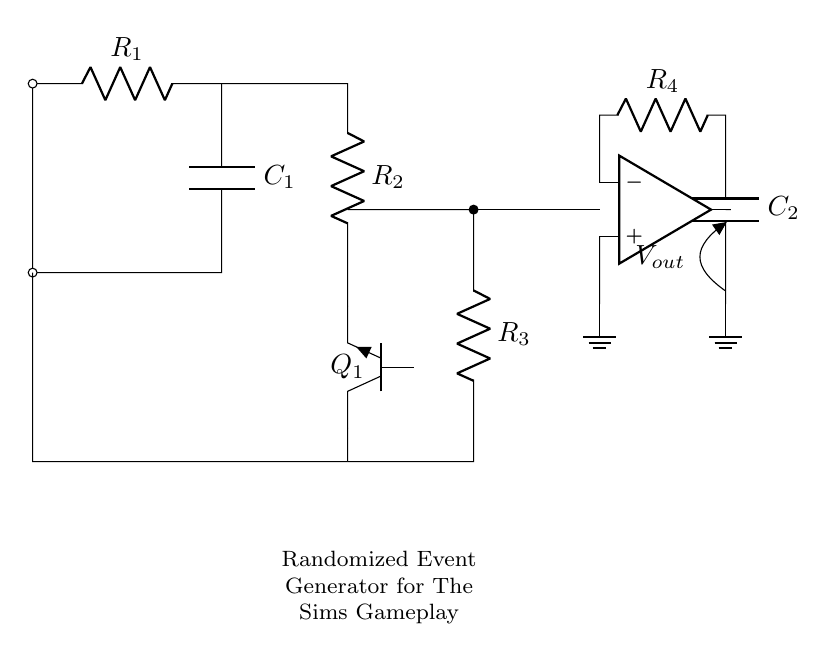What is the function of the capacitor in this circuit? The capacitor in this circuit is responsible for storing and releasing energy, which contributes to the timing and oscillation behavior of the relaxation oscillator. Specifically, it helps to create the charge and discharge cycles that produce randomized events.
Answer: Energy storage What type of transistor is used in this circuit? The circuit features an NPN transistor, typically used in oscillators for switching and amplification purposes. Its designation as Q1 indicates it is the primary component responsible for initiating the oscillation.
Answer: NPN What is the role of resistor R1? Resistor R1 is essential for limiting the current flowing into the charging capacitor, which in turn affects the time it takes to charge and discharge, influencing the frequency of oscillation.
Answer: Current limiting How many resistors are present in the circuit? Upon examining the circuit diagram, we count four resistors labeled R1, R2, R3, and R4, indicating their presence in the oscillation and timing functions of the circuit.
Answer: Four What type of oscillator is this circuit designed to create? The circuit is designed to create a relaxation oscillator, which produces a non-sinusoidal output waveform, typically generating a square or sawtooth signal suitable for randomization in gameplay mechanics.
Answer: Relaxation oscillator What is the function of the op-amp in this circuit? The operational amplifier in this circuit is used to compare voltages and potentially amplify the signal, contributing to the stability and functionality of the randomized events created by the oscillator.
Answer: Signal amplification 